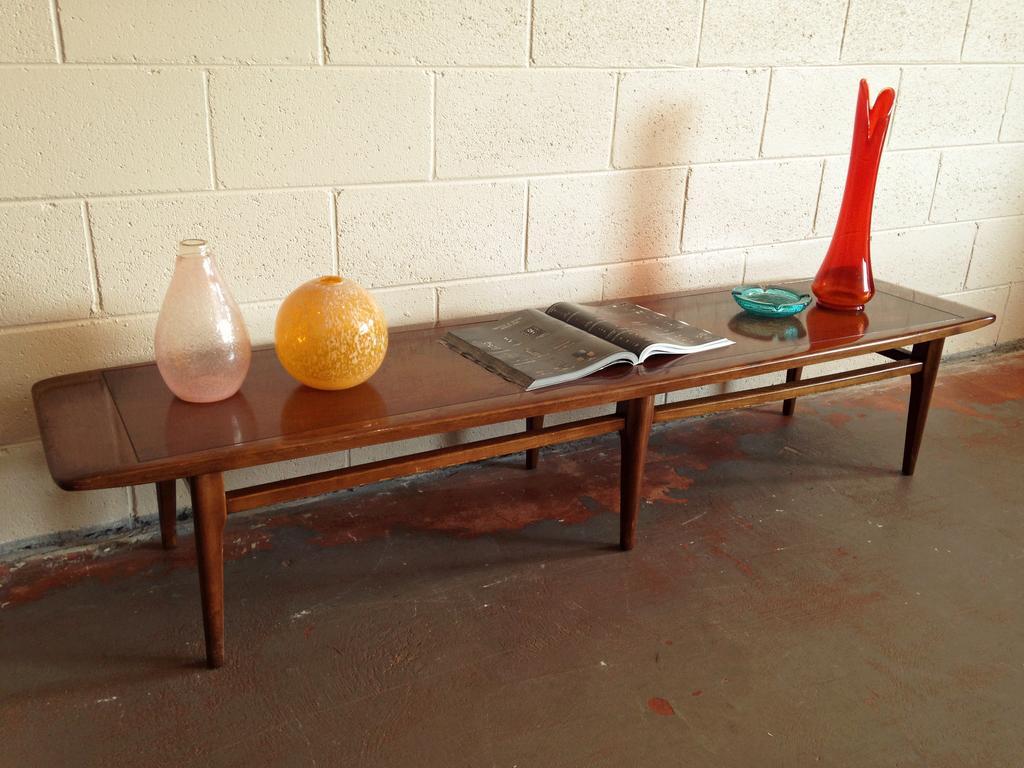Could you give a brief overview of what you see in this image? The picture consists of a bench, on the bench we can see glass items, book. In the background it is well. At the bottom there is floor. 